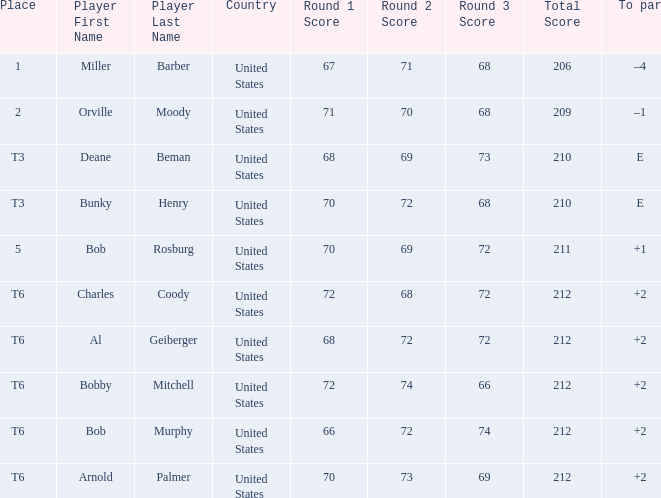What is the to par of player bunky henry? E. 